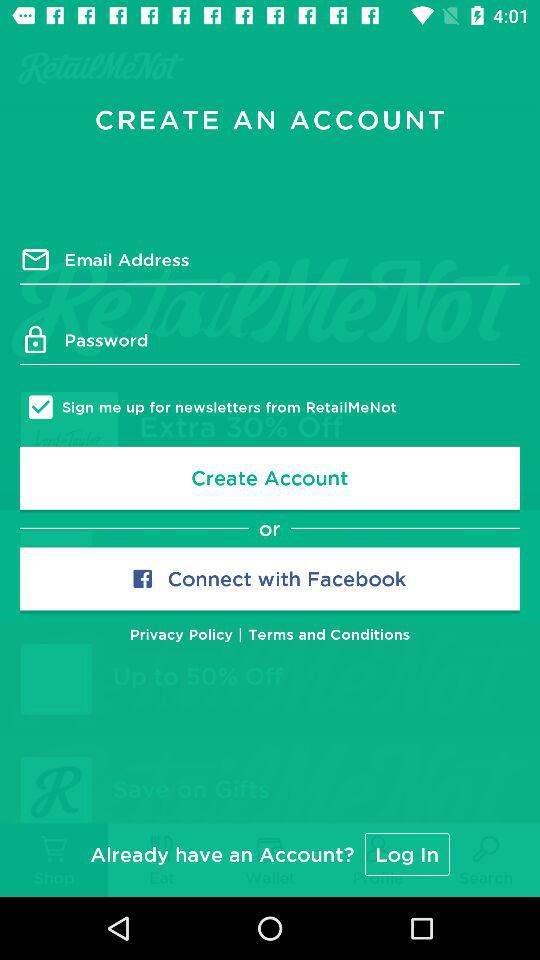Through what application can we connect? You can connect through "Facebook". 